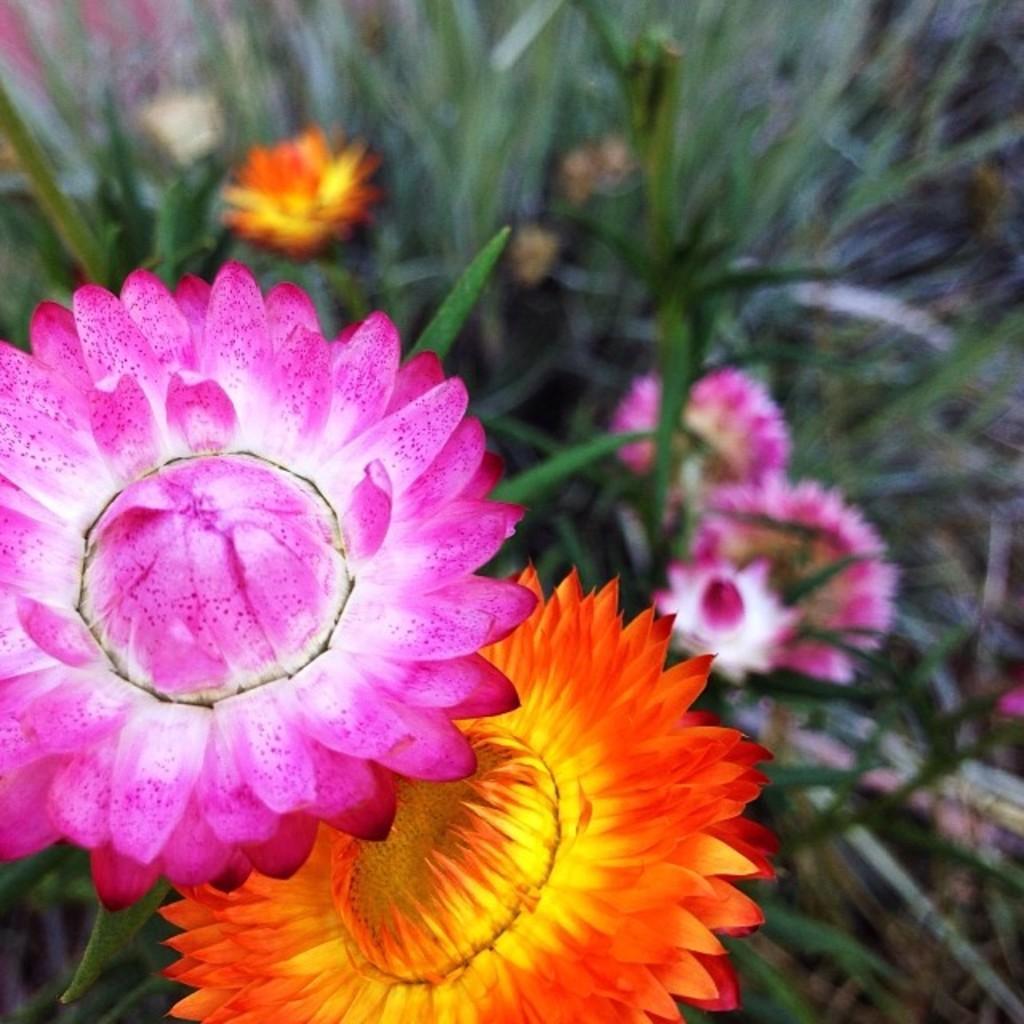In one or two sentences, can you explain what this image depicts? In this image I can see the plants along with the flowers. The flowers are in pink and orange colors. The leaves are in green color. 